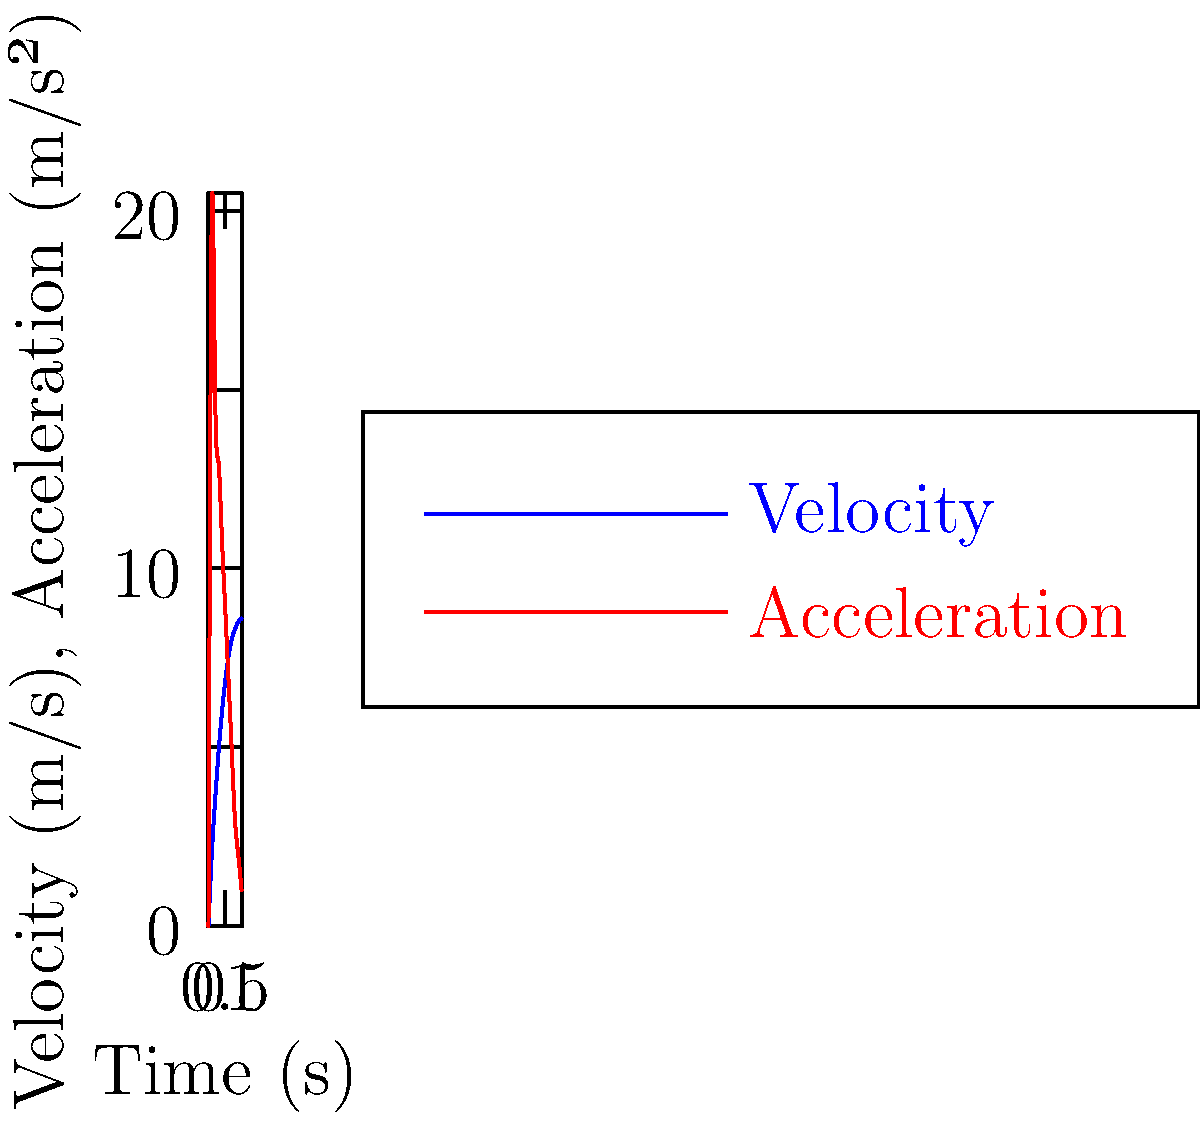During a layup, the velocity and acceleration of a player's arm are measured and plotted in the graph above. At what time does the arm reach its maximum velocity, and what is the corresponding acceleration at this point? How might this information be used to assess injury risk? To solve this problem, we need to follow these steps:

1. Identify the maximum velocity from the blue curve (velocity):
   The velocity curve reaches its peak at t = 1.0 s, with a velocity of 8.6 m/s.

2. Find the corresponding acceleration at t = 1.0 s from the red curve (acceleration):
   At t = 1.0 s, the acceleration is 1 m/s².

3. Assessing injury risk:
   a) The point of maximum velocity (8.6 m/s) represents the moment when the arm is moving fastest during the layup.
   b) The low acceleration (1 m/s²) at this point indicates that the arm is no longer increasing in speed significantly.
   c) The combination of high velocity and low acceleration suggests that the arm is about to decelerate rapidly.
   d) This rapid deceleration after reaching maximum velocity could potentially lead to stress on joints and muscles, increasing injury risk.
   e) Coaches and trainers can use this information to:
      - Develop training programs that focus on controlled deceleration
      - Teach proper layup techniques that minimize abrupt changes in arm velocity
      - Design strength and flexibility exercises targeting the muscles and joints involved in this motion

By understanding the velocity and acceleration profiles of the arm during a layup, players can work on optimizing their technique to reduce the risk of injuries associated with rapid changes in limb movement.
Answer: Maximum velocity at t = 1.0 s, acceleration = 1 m/s². High velocity with low acceleration indicates potential rapid deceleration, increasing injury risk. 